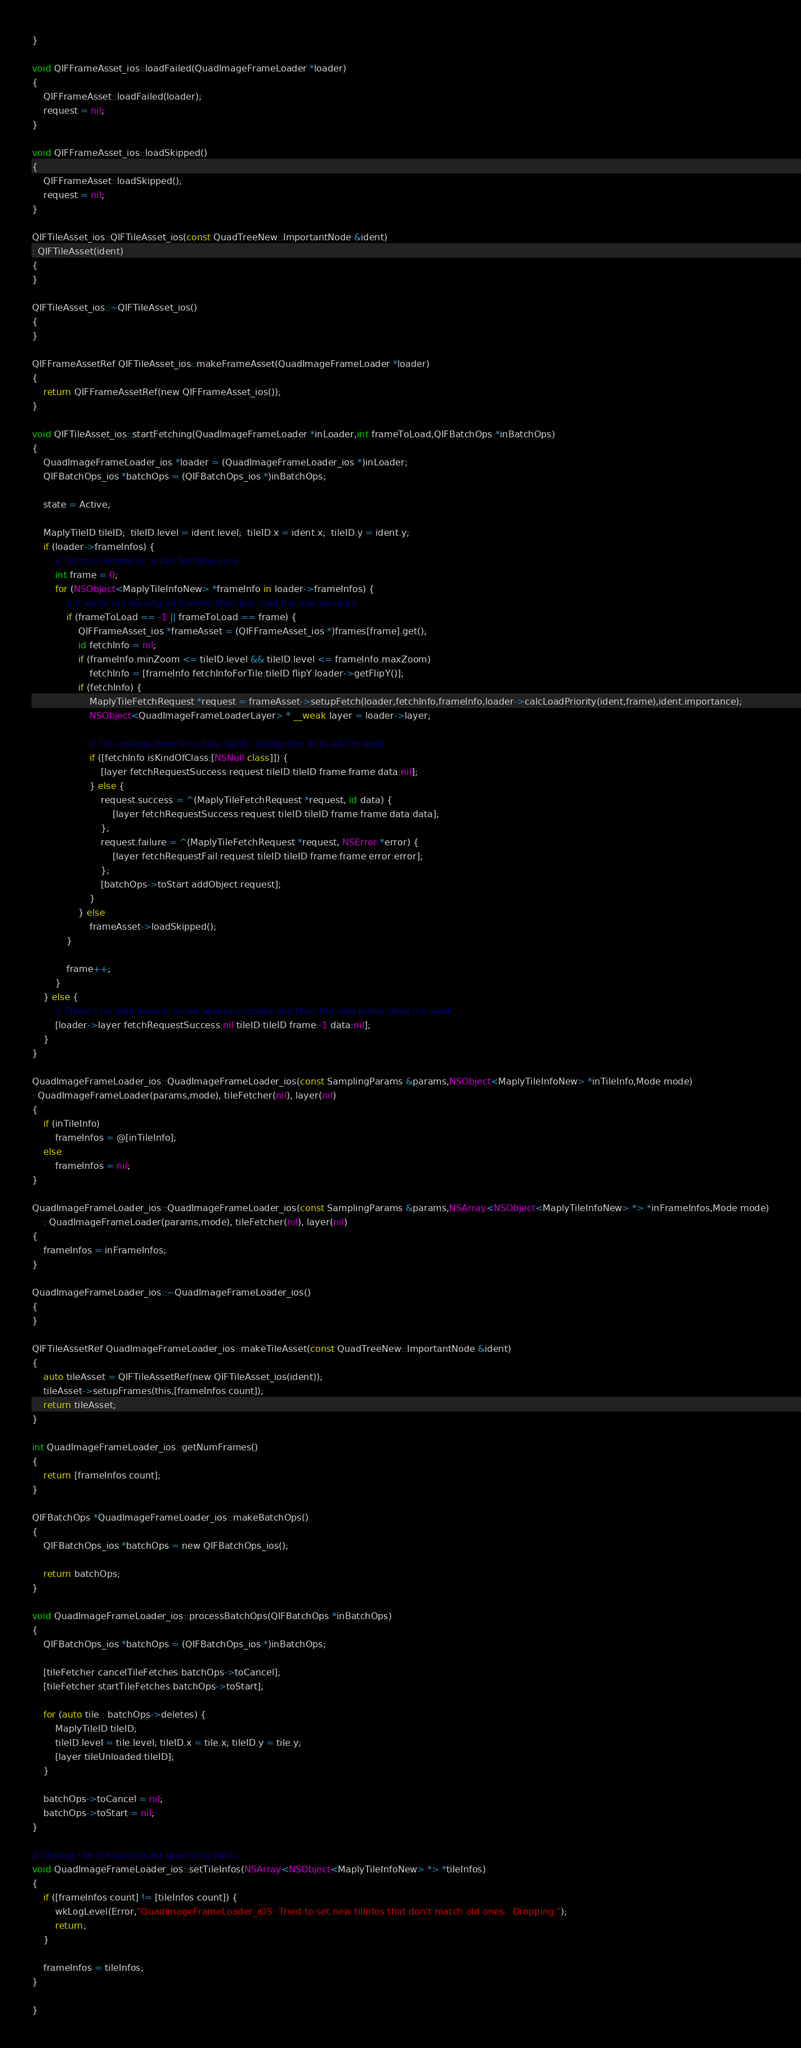<code> <loc_0><loc_0><loc_500><loc_500><_ObjectiveC_>}

void QIFFrameAsset_ios::loadFailed(QuadImageFrameLoader *loader)
{
    QIFFrameAsset::loadFailed(loader);
    request = nil;
}
    
void QIFFrameAsset_ios::loadSkipped()
{
    QIFFrameAsset::loadSkipped();
    request = nil;
}
    
QIFTileAsset_ios::QIFTileAsset_ios(const QuadTreeNew::ImportantNode &ident)
: QIFTileAsset(ident)
{
}
    
QIFTileAsset_ios::~QIFTileAsset_ios()
{
}
    
QIFFrameAssetRef QIFTileAsset_ios::makeFrameAsset(QuadImageFrameLoader *loader)
{
    return QIFFrameAssetRef(new QIFFrameAsset_ios());
}
    
void QIFTileAsset_ios::startFetching(QuadImageFrameLoader *inLoader,int frameToLoad,QIFBatchOps *inBatchOps)
{
    QuadImageFrameLoader_ios *loader = (QuadImageFrameLoader_ios *)inLoader;
    QIFBatchOps_ios *batchOps = (QIFBatchOps_ios *)inBatchOps;

    state = Active;
    
    MaplyTileID tileID;  tileID.level = ident.level;  tileID.x = ident.x;  tileID.y = ident.y;
    if (loader->frameInfos) {
        // Normal remote (or local) fetching case
        int frame = 0;
        for (NSObject<MaplyTileInfoNew> *frameInfo in loader->frameInfos) {
            // If we're not loading all frames, then just load the one we need
            if (frameToLoad == -1 || frameToLoad == frame) {
                QIFFrameAsset_ios *frameAsset = (QIFFrameAsset_ios *)frames[frame].get();
                id fetchInfo = nil;
                if (frameInfo.minZoom <= tileID.level && tileID.level <= frameInfo.maxZoom)
                    fetchInfo = [frameInfo fetchInfoForTile:tileID flipY:loader->getFlipY()];
                if (fetchInfo) {
                    MaplyTileFetchRequest *request = frameAsset->setupFetch(loader,fetchInfo,frameInfo,loader->calcLoadPriority(ident,frame),ident.importance);
                    NSObject<QuadImageFrameLoaderLayer> * __weak layer = loader->layer;

                    // This means there's no data fetch.  Interpreter does all the work.
                    if ([fetchInfo isKindOfClass:[NSNull class]]) {
                        [layer fetchRequestSuccess:request tileID:tileID frame:frame data:nil];
                    } else {
                        request.success = ^(MaplyTileFetchRequest *request, id data) {
                            [layer fetchRequestSuccess:request tileID:tileID frame:frame data:data];
                        };
                        request.failure = ^(MaplyTileFetchRequest *request, NSError *error) {
                            [layer fetchRequestFail:request tileID:tileID frame:frame error:error];
                        };
                        [batchOps->toStart addObject:request];
                    }
                } else
                    frameAsset->loadSkipped();
            }
                
            frame++;
        }
    } else {
        // There's no data source, so we always succeed and then the interpreter does the work
        [loader->layer fetchRequestSuccess:nil tileID:tileID frame:-1 data:nil];
    }
}
    
QuadImageFrameLoader_ios::QuadImageFrameLoader_ios(const SamplingParams &params,NSObject<MaplyTileInfoNew> *inTileInfo,Mode mode)
: QuadImageFrameLoader(params,mode), tileFetcher(nil), layer(nil)
{
    if (inTileInfo)
        frameInfos = @[inTileInfo];
    else
        frameInfos = nil;
}

QuadImageFrameLoader_ios::QuadImageFrameLoader_ios(const SamplingParams &params,NSArray<NSObject<MaplyTileInfoNew> *> *inFrameInfos,Mode mode)
    : QuadImageFrameLoader(params,mode), tileFetcher(nil), layer(nil)
{
    frameInfos = inFrameInfos;
}
    
QuadImageFrameLoader_ios::~QuadImageFrameLoader_ios()
{
}

QIFTileAssetRef QuadImageFrameLoader_ios::makeTileAsset(const QuadTreeNew::ImportantNode &ident)
{
    auto tileAsset = QIFTileAssetRef(new QIFTileAsset_ios(ident));
    tileAsset->setupFrames(this,[frameInfos count]);
    return tileAsset;
}
    
int QuadImageFrameLoader_ios::getNumFrames()
{
    return [frameInfos count];
}
    
QIFBatchOps *QuadImageFrameLoader_ios::makeBatchOps()
{
    QIFBatchOps_ios *batchOps = new QIFBatchOps_ios();
    
    return batchOps;
}
    
void QuadImageFrameLoader_ios::processBatchOps(QIFBatchOps *inBatchOps)
{
    QIFBatchOps_ios *batchOps = (QIFBatchOps_ios *)inBatchOps;

    [tileFetcher cancelTileFetches:batchOps->toCancel];
    [tileFetcher startTileFetches:batchOps->toStart];

    for (auto tile : batchOps->deletes) {
        MaplyTileID tileID;
        tileID.level = tile.level; tileID.x = tile.x; tileID.y = tile.y;
        [layer tileUnloaded:tileID];
    }
    
    batchOps->toCancel = nil;
    batchOps->toStart = nil;
}
    
// Change the tile sources for upcoming loads
void QuadImageFrameLoader_ios::setTileInfos(NSArray<NSObject<MaplyTileInfoNew> *> *tileInfos)
{
    if ([frameInfos count] != [tileInfos count]) {
        wkLogLevel(Error,"QuadImageFrameLoader_iOS: Tried to set new tilInfos that don't match old ones.  Dropping.");
        return;
    }
    
    frameInfos = tileInfos;
}

}
</code> 